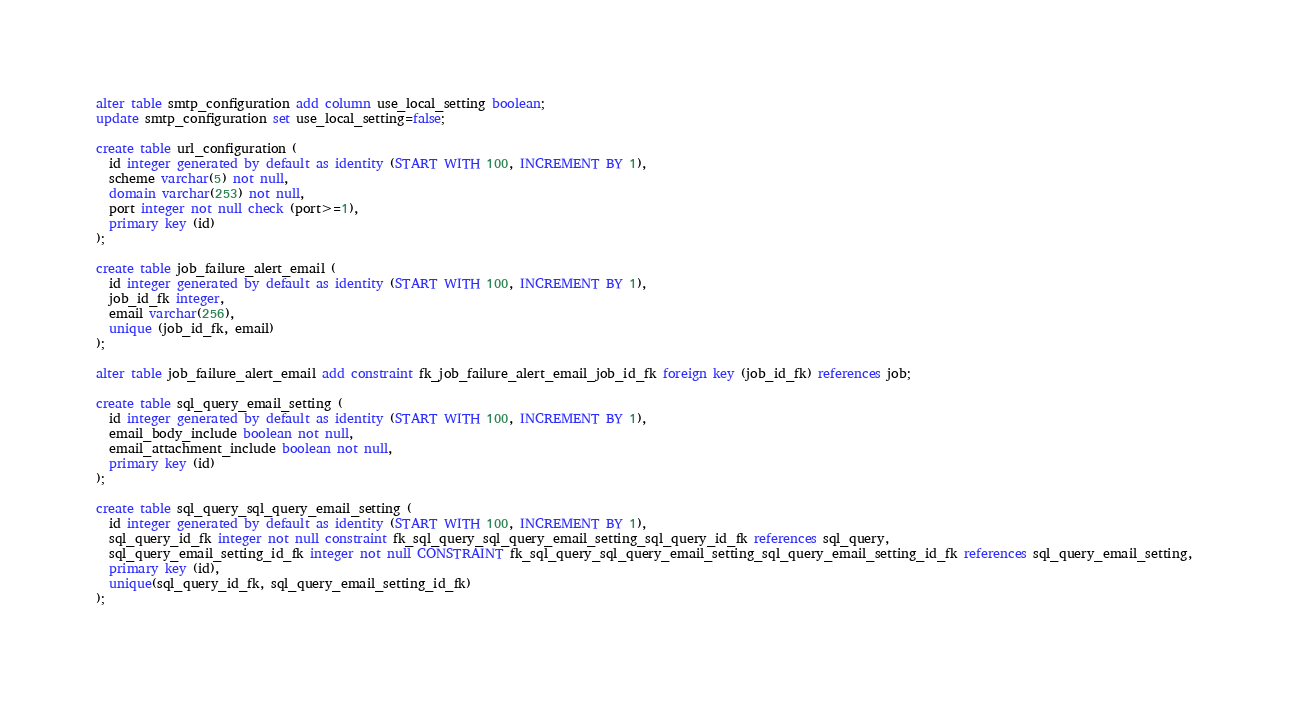<code> <loc_0><loc_0><loc_500><loc_500><_SQL_>alter table smtp_configuration add column use_local_setting boolean;
update smtp_configuration set use_local_setting=false;

create table url_configuration (
  id integer generated by default as identity (START WITH 100, INCREMENT BY 1),
  scheme varchar(5) not null,
  domain varchar(253) not null,
  port integer not null check (port>=1),
  primary key (id)
);

create table job_failure_alert_email (
  id integer generated by default as identity (START WITH 100, INCREMENT BY 1),
  job_id_fk integer,
  email varchar(256),
  unique (job_id_fk, email)
);

alter table job_failure_alert_email add constraint fk_job_failure_alert_email_job_id_fk foreign key (job_id_fk) references job;

create table sql_query_email_setting (
  id integer generated by default as identity (START WITH 100, INCREMENT BY 1),
  email_body_include boolean not null,
  email_attachment_include boolean not null,
  primary key (id)
);

create table sql_query_sql_query_email_setting (
  id integer generated by default as identity (START WITH 100, INCREMENT BY 1),
  sql_query_id_fk integer not null constraint fk_sql_query_sql_query_email_setting_sql_query_id_fk references sql_query,
  sql_query_email_setting_id_fk integer not null CONSTRAINT fk_sql_query_sql_query_email_setting_sql_query_email_setting_id_fk references sql_query_email_setting,
  primary key (id),
  unique(sql_query_id_fk, sql_query_email_setting_id_fk)
);

</code> 